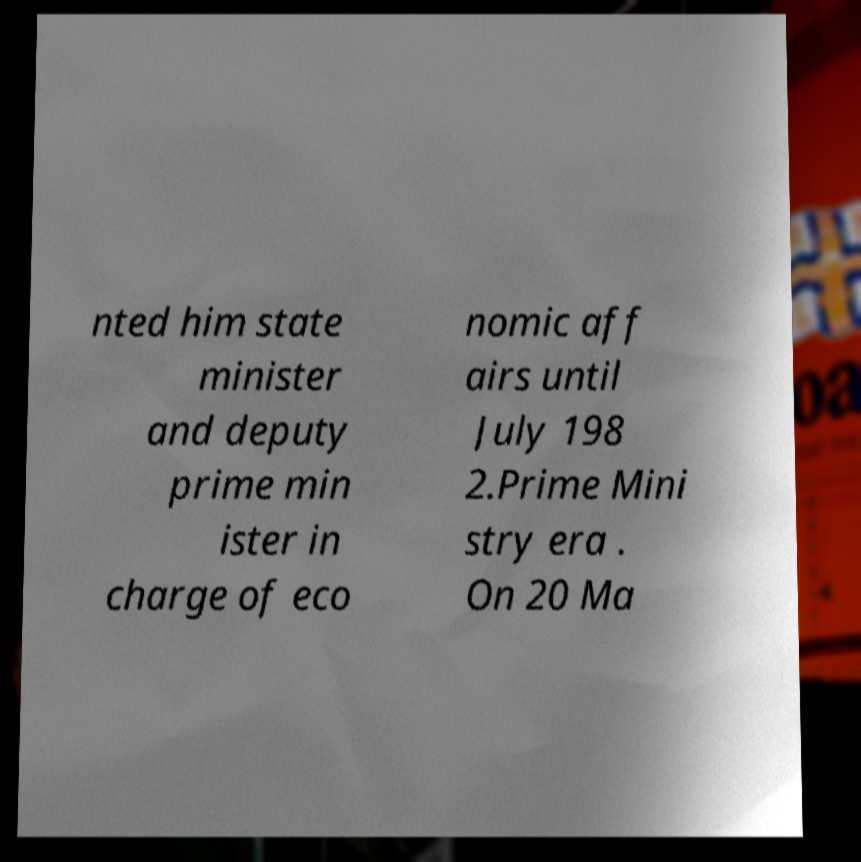I need the written content from this picture converted into text. Can you do that? nted him state minister and deputy prime min ister in charge of eco nomic aff airs until July 198 2.Prime Mini stry era . On 20 Ma 